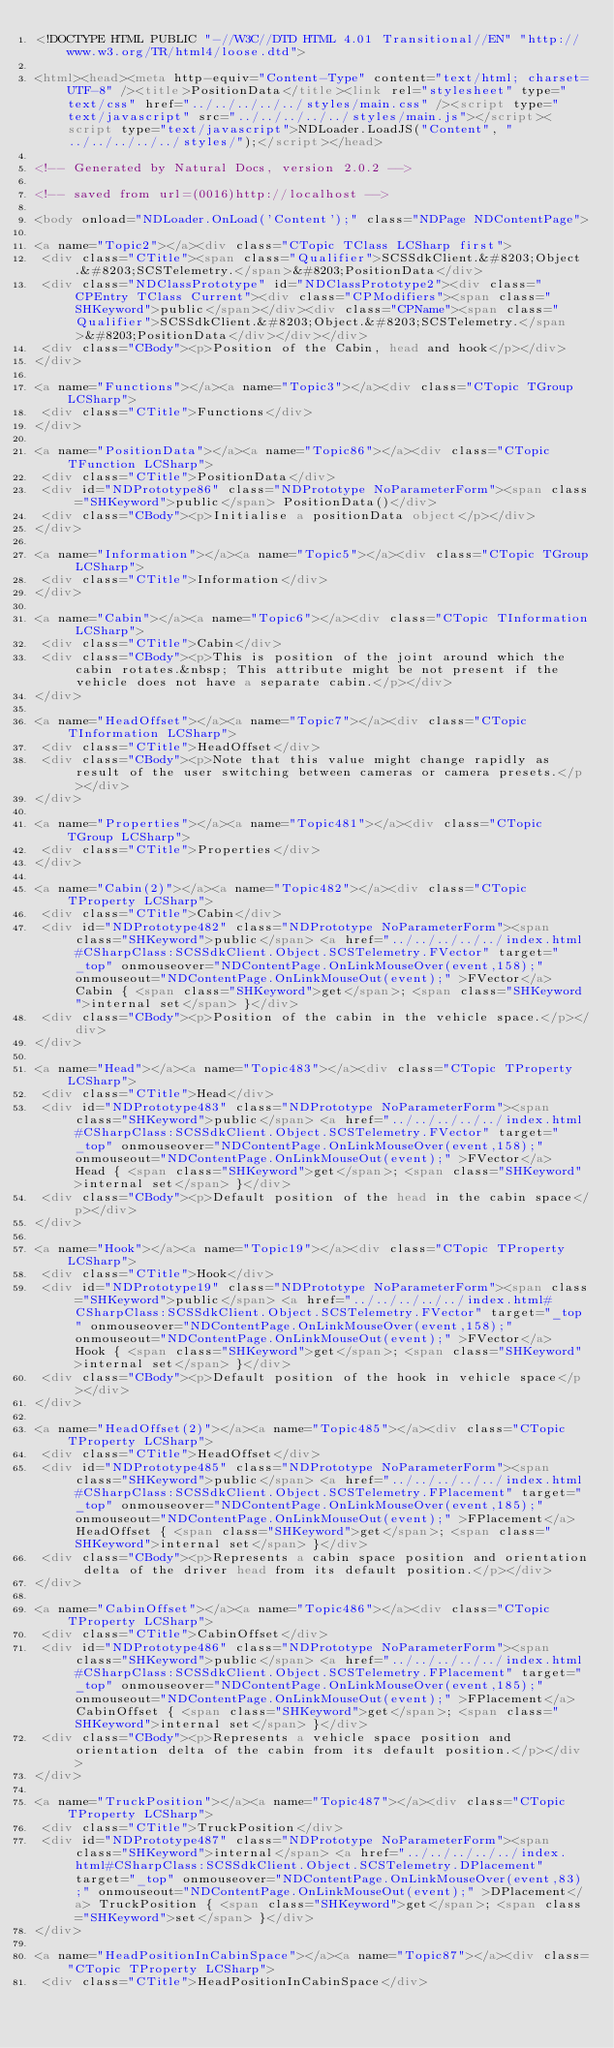Convert code to text. <code><loc_0><loc_0><loc_500><loc_500><_HTML_><!DOCTYPE HTML PUBLIC "-//W3C//DTD HTML 4.01 Transitional//EN" "http://www.w3.org/TR/html4/loose.dtd">

<html><head><meta http-equiv="Content-Type" content="text/html; charset=UTF-8" /><title>PositionData</title><link rel="stylesheet" type="text/css" href="../../../../../styles/main.css" /><script type="text/javascript" src="../../../../../styles/main.js"></script><script type="text/javascript">NDLoader.LoadJS("Content", "../../../../../styles/");</script></head>

<!-- Generated by Natural Docs, version 2.0.2 -->

<!-- saved from url=(0016)http://localhost -->

<body onload="NDLoader.OnLoad('Content');" class="NDPage NDContentPage">

<a name="Topic2"></a><div class="CTopic TClass LCSharp first">
 <div class="CTitle"><span class="Qualifier">SCSSdkClient.&#8203;Object.&#8203;SCSTelemetry.</span>&#8203;PositionData</div>
 <div class="NDClassPrototype" id="NDClassPrototype2"><div class="CPEntry TClass Current"><div class="CPModifiers"><span class="SHKeyword">public</span></div><div class="CPName"><span class="Qualifier">SCSSdkClient.&#8203;Object.&#8203;SCSTelemetry.</span>&#8203;PositionData</div></div></div>
 <div class="CBody"><p>Position of the Cabin, head and hook</p></div>
</div>

<a name="Functions"></a><a name="Topic3"></a><div class="CTopic TGroup LCSharp">
 <div class="CTitle">Functions</div>
</div>

<a name="PositionData"></a><a name="Topic86"></a><div class="CTopic TFunction LCSharp">
 <div class="CTitle">PositionData</div>
 <div id="NDPrototype86" class="NDPrototype NoParameterForm"><span class="SHKeyword">public</span> PositionData()</div>
 <div class="CBody"><p>Initialise a positionData object</p></div>
</div>

<a name="Information"></a><a name="Topic5"></a><div class="CTopic TGroup LCSharp">
 <div class="CTitle">Information</div>
</div>

<a name="Cabin"></a><a name="Topic6"></a><div class="CTopic TInformation LCSharp">
 <div class="CTitle">Cabin</div>
 <div class="CBody"><p>This is position of the joint around which the cabin rotates.&nbsp; This attribute might be not present if the vehicle does not have a separate cabin.</p></div>
</div>

<a name="HeadOffset"></a><a name="Topic7"></a><div class="CTopic TInformation LCSharp">
 <div class="CTitle">HeadOffset</div>
 <div class="CBody"><p>Note that this value might change rapidly as result of the user switching between cameras or camera presets.</p></div>
</div>

<a name="Properties"></a><a name="Topic481"></a><div class="CTopic TGroup LCSharp">
 <div class="CTitle">Properties</div>
</div>

<a name="Cabin(2)"></a><a name="Topic482"></a><div class="CTopic TProperty LCSharp">
 <div class="CTitle">Cabin</div>
 <div id="NDPrototype482" class="NDPrototype NoParameterForm"><span class="SHKeyword">public</span> <a href="../../../../../index.html#CSharpClass:SCSSdkClient.Object.SCSTelemetry.FVector" target="_top" onmouseover="NDContentPage.OnLinkMouseOver(event,158);" onmouseout="NDContentPage.OnLinkMouseOut(event);" >FVector</a> Cabin { <span class="SHKeyword">get</span>; <span class="SHKeyword">internal set</span> }</div>
 <div class="CBody"><p>Position of the cabin in the vehicle space.</p></div>
</div>

<a name="Head"></a><a name="Topic483"></a><div class="CTopic TProperty LCSharp">
 <div class="CTitle">Head</div>
 <div id="NDPrototype483" class="NDPrototype NoParameterForm"><span class="SHKeyword">public</span> <a href="../../../../../index.html#CSharpClass:SCSSdkClient.Object.SCSTelemetry.FVector" target="_top" onmouseover="NDContentPage.OnLinkMouseOver(event,158);" onmouseout="NDContentPage.OnLinkMouseOut(event);" >FVector</a> Head { <span class="SHKeyword">get</span>; <span class="SHKeyword">internal set</span> }</div>
 <div class="CBody"><p>Default position of the head in the cabin space</p></div>
</div>

<a name="Hook"></a><a name="Topic19"></a><div class="CTopic TProperty LCSharp">
 <div class="CTitle">Hook</div>
 <div id="NDPrototype19" class="NDPrototype NoParameterForm"><span class="SHKeyword">public</span> <a href="../../../../../index.html#CSharpClass:SCSSdkClient.Object.SCSTelemetry.FVector" target="_top" onmouseover="NDContentPage.OnLinkMouseOver(event,158);" onmouseout="NDContentPage.OnLinkMouseOut(event);" >FVector</a> Hook { <span class="SHKeyword">get</span>; <span class="SHKeyword">internal set</span> }</div>
 <div class="CBody"><p>Default position of the hook in vehicle space</p></div>
</div>

<a name="HeadOffset(2)"></a><a name="Topic485"></a><div class="CTopic TProperty LCSharp">
 <div class="CTitle">HeadOffset</div>
 <div id="NDPrototype485" class="NDPrototype NoParameterForm"><span class="SHKeyword">public</span> <a href="../../../../../index.html#CSharpClass:SCSSdkClient.Object.SCSTelemetry.FPlacement" target="_top" onmouseover="NDContentPage.OnLinkMouseOver(event,185);" onmouseout="NDContentPage.OnLinkMouseOut(event);" >FPlacement</a> HeadOffset { <span class="SHKeyword">get</span>; <span class="SHKeyword">internal set</span> }</div>
 <div class="CBody"><p>Represents a cabin space position and orientation delta of the driver head from its default position.</p></div>
</div>

<a name="CabinOffset"></a><a name="Topic486"></a><div class="CTopic TProperty LCSharp">
 <div class="CTitle">CabinOffset</div>
 <div id="NDPrototype486" class="NDPrototype NoParameterForm"><span class="SHKeyword">public</span> <a href="../../../../../index.html#CSharpClass:SCSSdkClient.Object.SCSTelemetry.FPlacement" target="_top" onmouseover="NDContentPage.OnLinkMouseOver(event,185);" onmouseout="NDContentPage.OnLinkMouseOut(event);" >FPlacement</a> CabinOffset { <span class="SHKeyword">get</span>; <span class="SHKeyword">internal set</span> }</div>
 <div class="CBody"><p>Represents a vehicle space position and orientation delta of the cabin from its default position.</p></div>
</div>

<a name="TruckPosition"></a><a name="Topic487"></a><div class="CTopic TProperty LCSharp">
 <div class="CTitle">TruckPosition</div>
 <div id="NDPrototype487" class="NDPrototype NoParameterForm"><span class="SHKeyword">internal</span> <a href="../../../../../index.html#CSharpClass:SCSSdkClient.Object.SCSTelemetry.DPlacement" target="_top" onmouseover="NDContentPage.OnLinkMouseOver(event,83);" onmouseout="NDContentPage.OnLinkMouseOut(event);" >DPlacement</a> TruckPosition { <span class="SHKeyword">get</span>; <span class="SHKeyword">set</span> }</div>
</div>

<a name="HeadPositionInCabinSpace"></a><a name="Topic87"></a><div class="CTopic TProperty LCSharp">
 <div class="CTitle">HeadPositionInCabinSpace</div></code> 